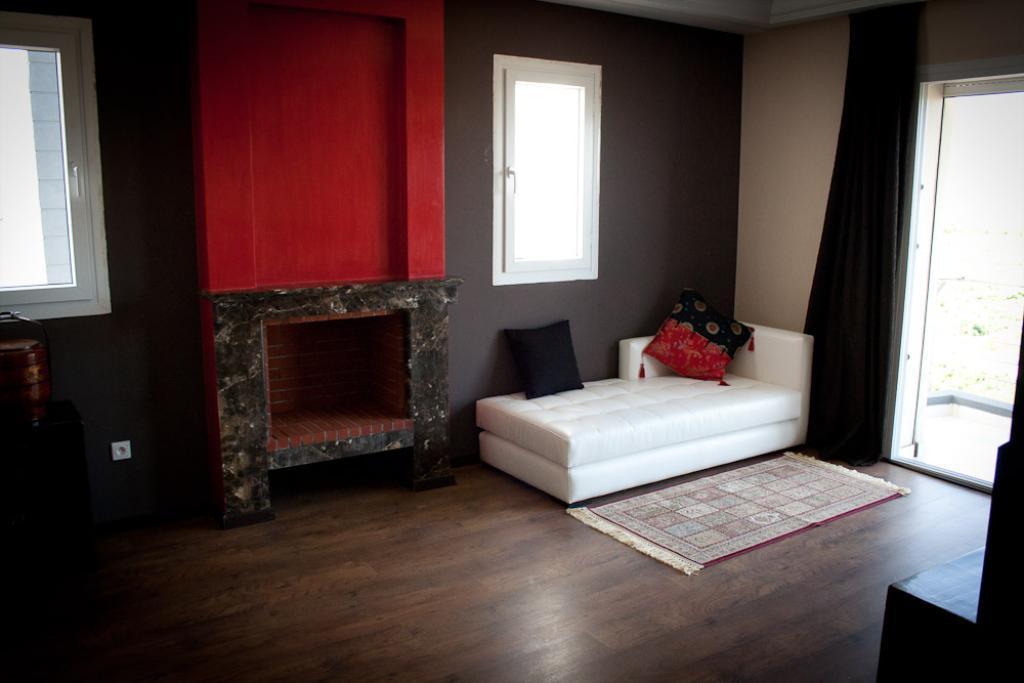Describe this image in one or two sentences. This picture shows an inner view of a room and we see a curtain and couple of Windows and we see a sofa bed and couple of cushions on it and we see a mat on the floor. 